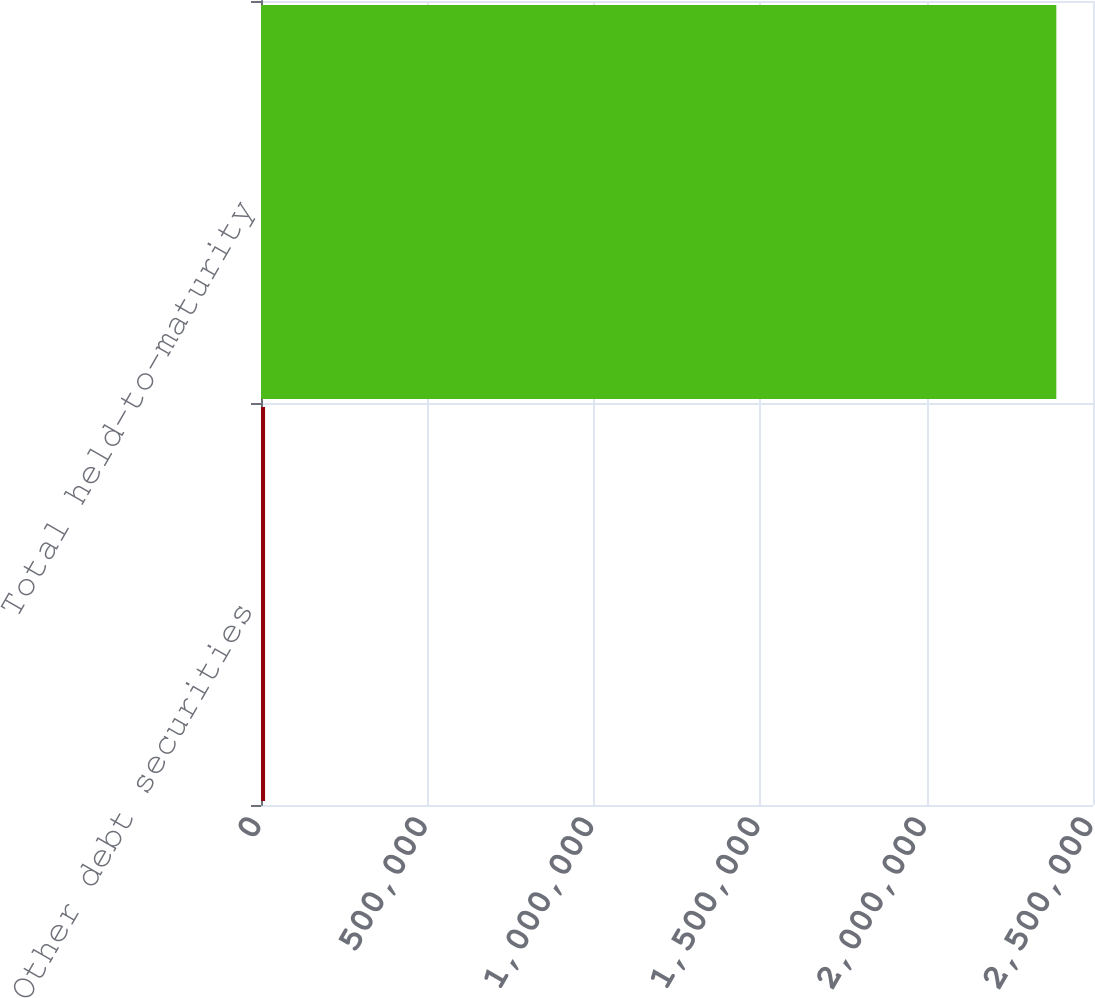Convert chart. <chart><loc_0><loc_0><loc_500><loc_500><bar_chart><fcel>Other debt securities<fcel>Total held-to-maturity<nl><fcel>12195<fcel>2.38982e+06<nl></chart> 